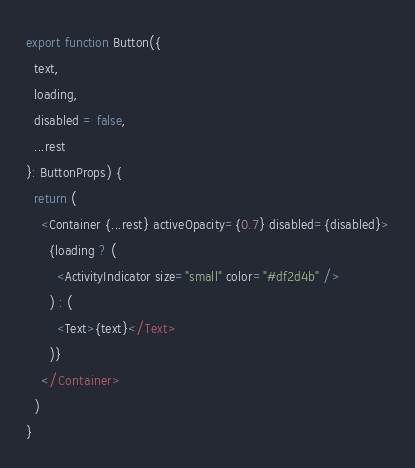<code> <loc_0><loc_0><loc_500><loc_500><_TypeScript_>export function Button({
  text,
  loading,
  disabled = false,
  ...rest
}: ButtonProps) {
  return (
    <Container {...rest} activeOpacity={0.7} disabled={disabled}>
      {loading ? (
        <ActivityIndicator size="small" color="#df2d4b" />
      ) : (
        <Text>{text}</Text>
      )}
    </Container>
  )
}
</code> 